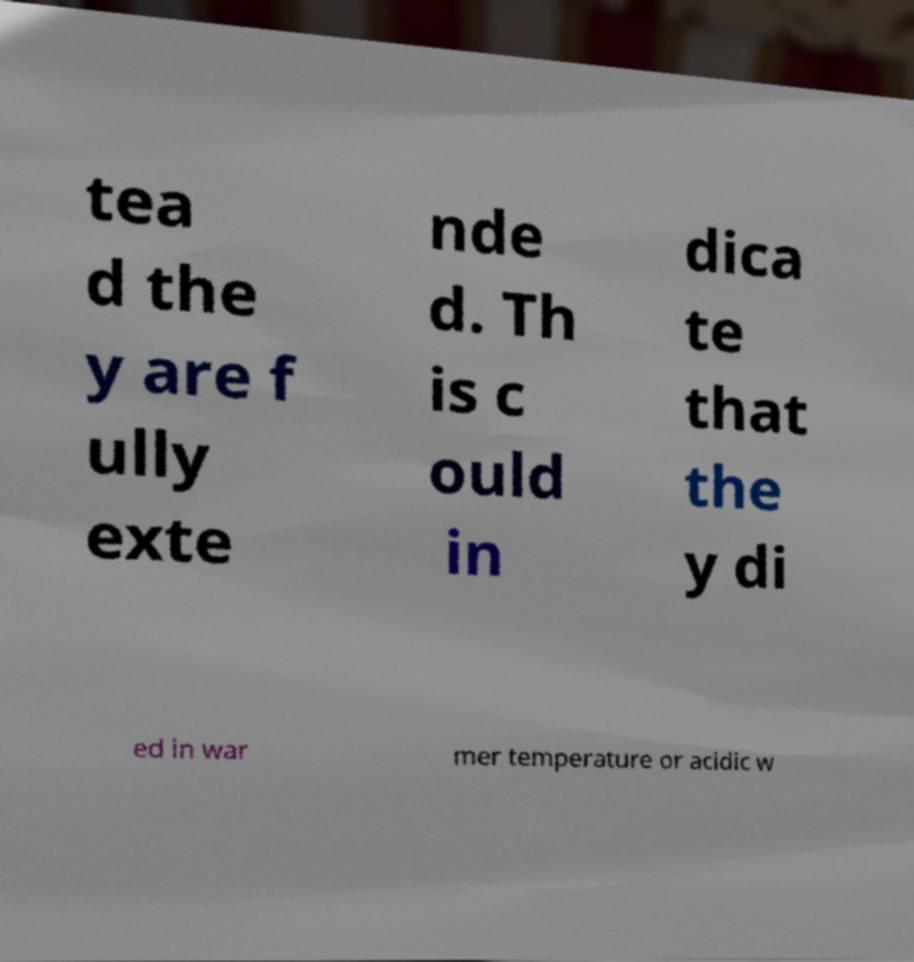There's text embedded in this image that I need extracted. Can you transcribe it verbatim? tea d the y are f ully exte nde d. Th is c ould in dica te that the y di ed in war mer temperature or acidic w 